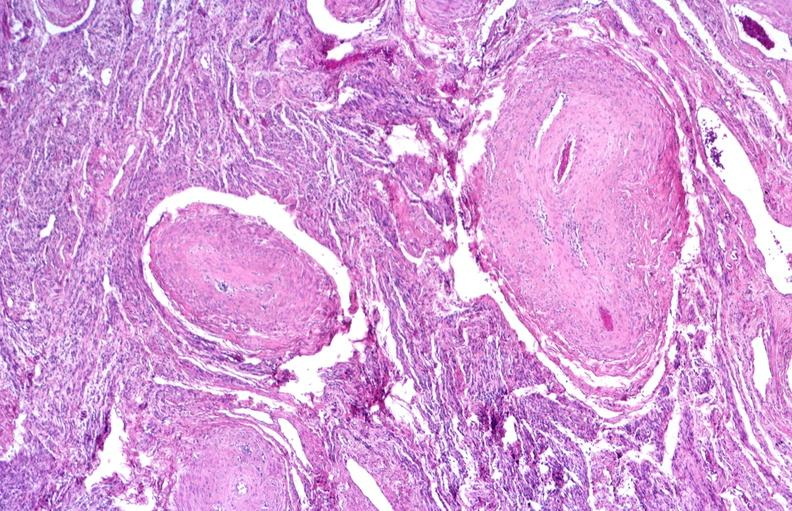where is this?
Answer the question using a single word or phrase. Urinary 